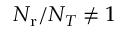Convert formula to latex. <formula><loc_0><loc_0><loc_500><loc_500>N _ { r } / N _ { T } \neq 1</formula> 